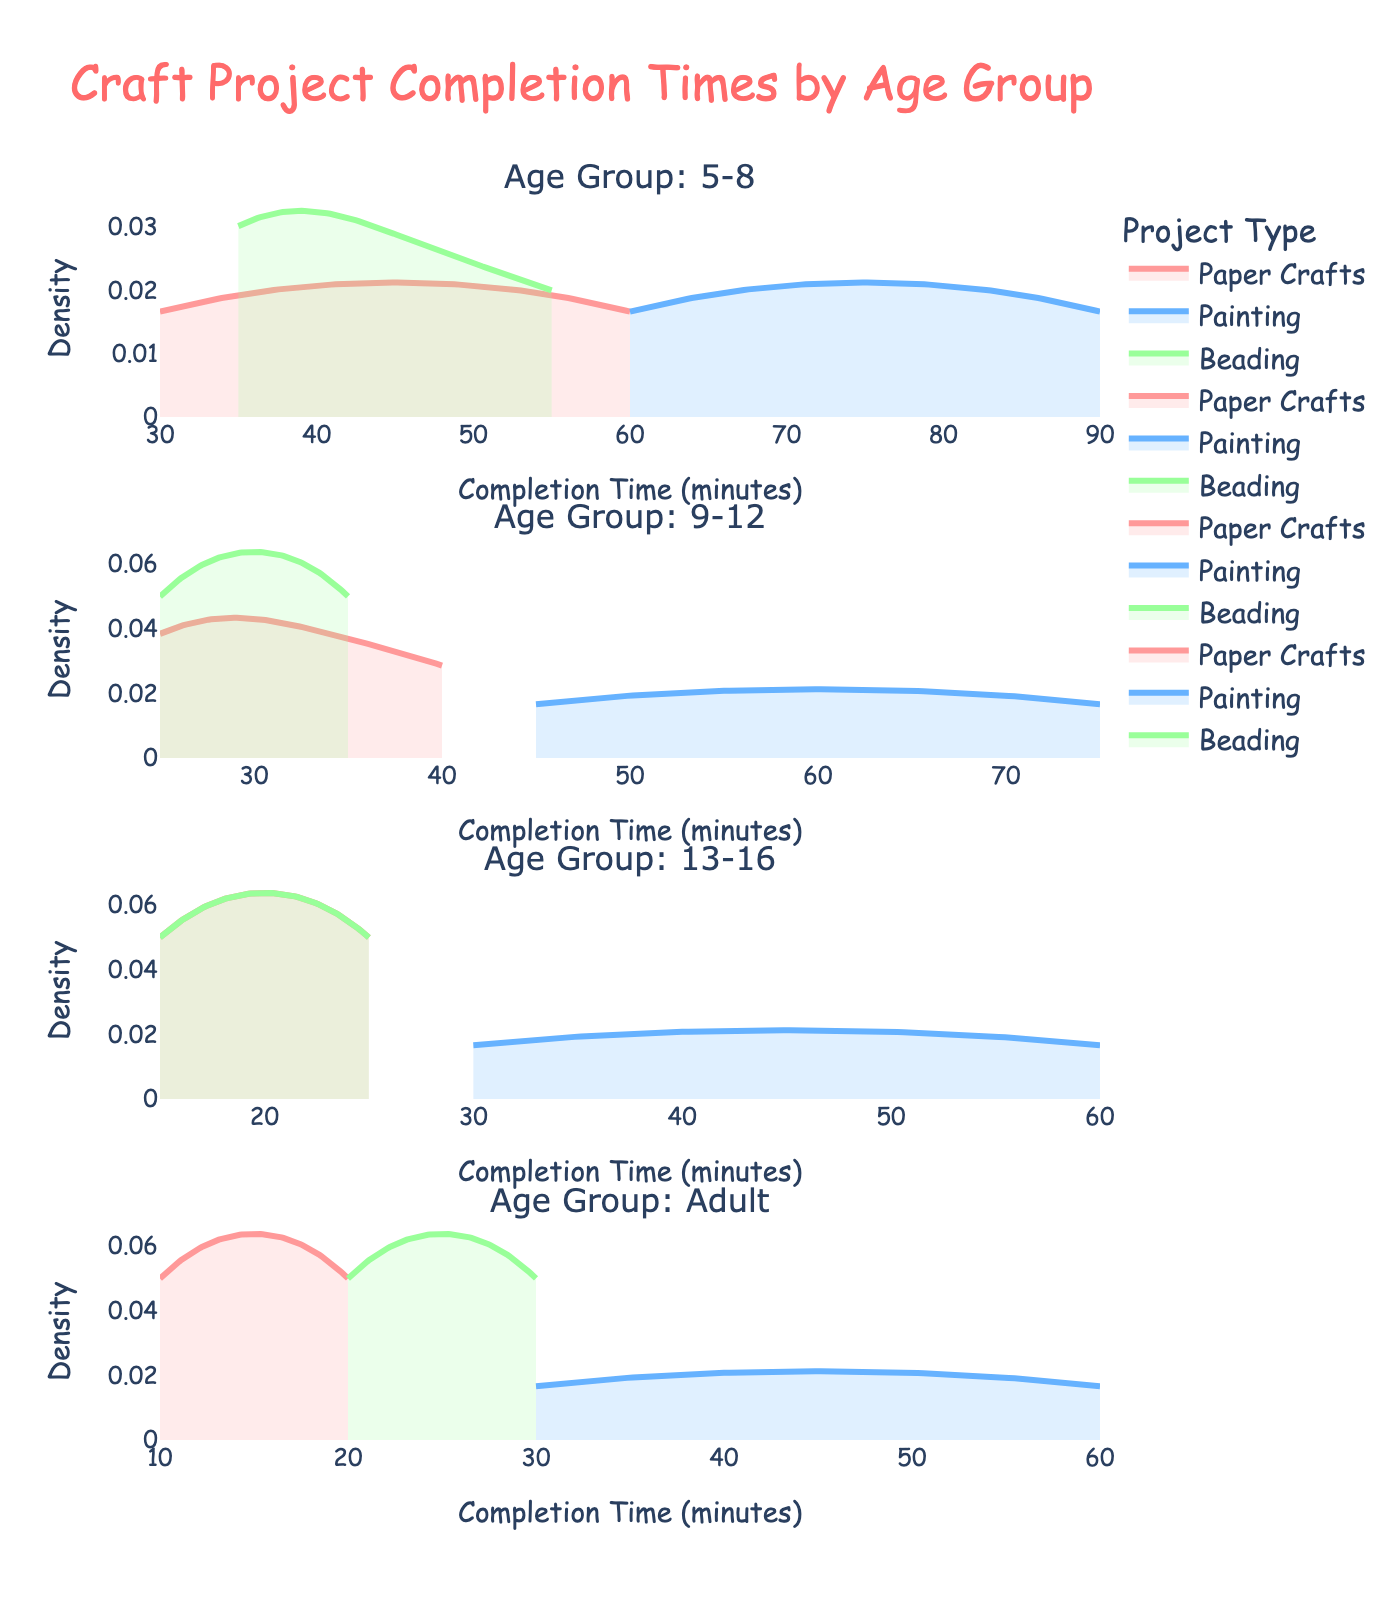Which age group tends to have the shortest completion times for Paper Crafts? By looking at the density plots for Paper Crafts across the different age groups, we can see that the peak of the density plot for the Adult group is at a lower completion time compared to other age groups.
Answer: Adult Which project type has the widest spread of completion times for the 5-8 age group? The density plots show that the Painting project for the 5-8 age group has a wider spread since it ranges from around 60 to 90 minutes, indicating a wider distribution.
Answer: Painting For the 13-16 age group, which project type has the highest peak density? By examining the density plots for the 13-16 age group, the peak density for Paper Crafts is higher than that of Painting and Beading, indicating that Paper Crafts completion times are more concentrated.
Answer: Paper Crafts How does the painting completion time for adults compare to that for the 9-12 age group? Comparing the density plots for Painting, the Adult group's completion time density plot reveals a range that peaks around 45 minutes, whereas the 9-12 age group shows a peak closer to 60 minutes. This suggests adults complete it faster on average.
Answer: Adults complete Painting faster on average than the 9-12 age group Do kids aged 5-8 or 9-12 have more consistent completion times for Beading projects? By comparing the density plots, Beading for the 9-12 age group has a narrower and higher density peak compared to the 5-8 age group, indicating more consistent completion times.
Answer: 9-12 Which age group's density plot for Paper Crafts completion time does not overlap with others? The Adult group's density plot for Paper Crafts is shifted completely to shorter completion times compared to other age groups, with no overlap visually.
Answer: Adult Which project type tends to be completed the quickest by the 5-8 age group? Observing the density plots for the 5-8 age group, Beading has the highest density around the lowest completion times, indicating it is the project type completed the quickest.
Answer: Beading Is the completion time for Beading projects longer for the 5-8 or the 13-16 age group? Comparing the density plots for Beading completion times for both age groups, the 5-8 age group has slightly longer times, as their plot peaks around 40-55 minutes, while the 13-16 group peaks around 15-25 minutes.
Answer: 5-8 Which age group has the most varied completion times across all project types? The density plots for the 5-8 age group show a larger spread across all project types, suggesting more varied completion times compared to other age groups.
Answer: 5-8 